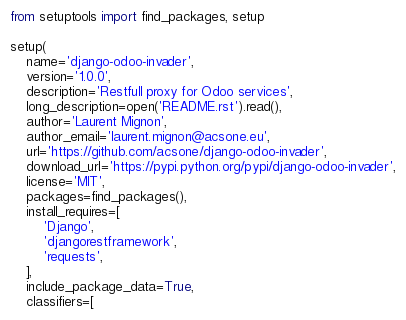Convert code to text. <code><loc_0><loc_0><loc_500><loc_500><_Python_>
from setuptools import find_packages, setup

setup(
    name='django-odoo-invader',
    version='1.0.0',
    description='Restfull proxy for Odoo services',
    long_description=open('README.rst').read(),
    author='Laurent Mignon',
    author_email='laurent.mignon@acsone.eu',
    url='https://github.com/acsone/django-odoo-invader',
    download_url='https://pypi.python.org/pypi/django-odoo-invader',
    license='MIT',
    packages=find_packages(),
    install_requires=[
        'Django',
        'djangorestframework',
        'requests',
    ],
    include_package_data=True,
    classifiers=[</code> 